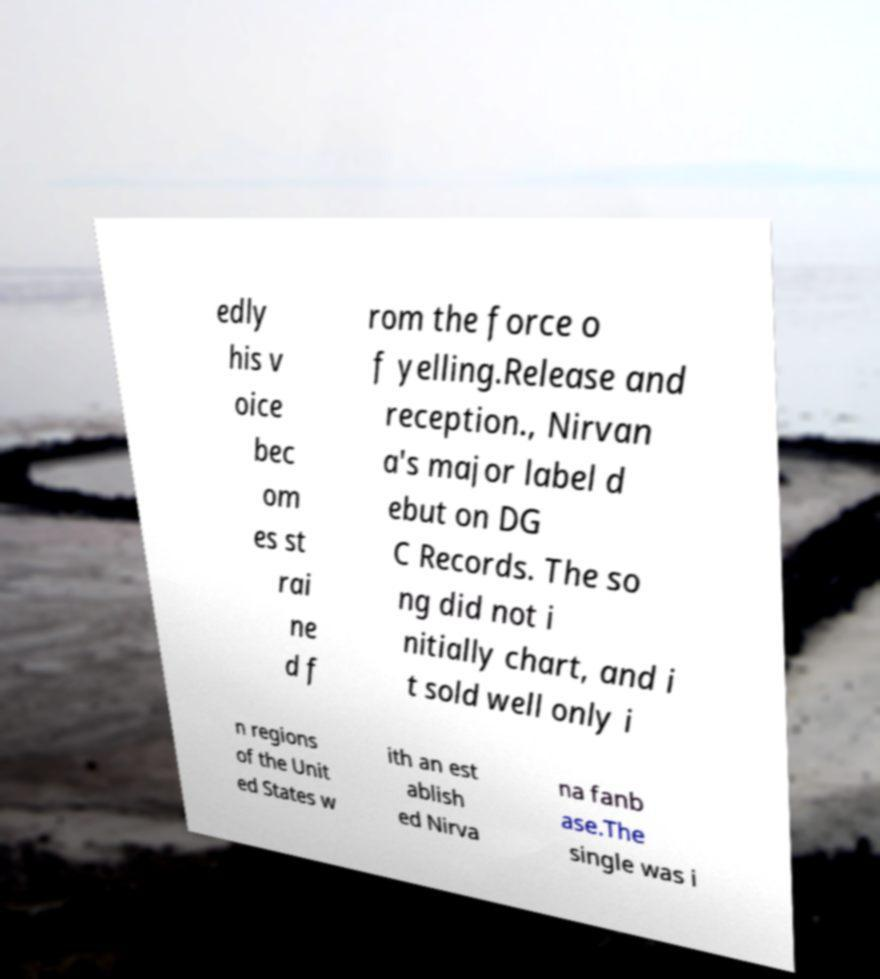What messages or text are displayed in this image? I need them in a readable, typed format. edly his v oice bec om es st rai ne d f rom the force o f yelling.Release and reception., Nirvan a's major label d ebut on DG C Records. The so ng did not i nitially chart, and i t sold well only i n regions of the Unit ed States w ith an est ablish ed Nirva na fanb ase.The single was i 